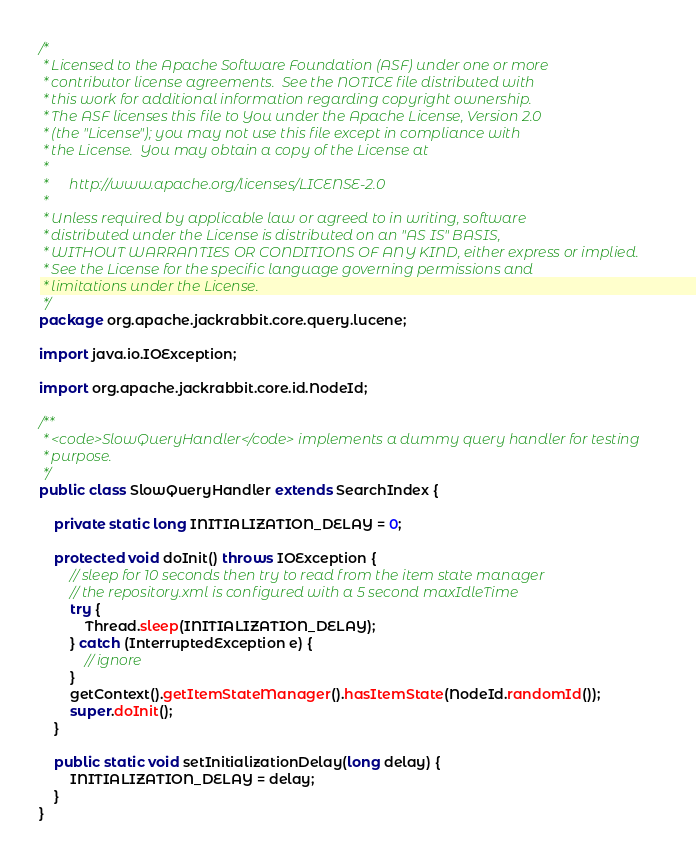<code> <loc_0><loc_0><loc_500><loc_500><_Java_>/*
 * Licensed to the Apache Software Foundation (ASF) under one or more
 * contributor license agreements.  See the NOTICE file distributed with
 * this work for additional information regarding copyright ownership.
 * The ASF licenses this file to You under the Apache License, Version 2.0
 * (the "License"); you may not use this file except in compliance with
 * the License.  You may obtain a copy of the License at
 *
 *      http://www.apache.org/licenses/LICENSE-2.0
 *
 * Unless required by applicable law or agreed to in writing, software
 * distributed under the License is distributed on an "AS IS" BASIS,
 * WITHOUT WARRANTIES OR CONDITIONS OF ANY KIND, either express or implied.
 * See the License for the specific language governing permissions and
 * limitations under the License.
 */
package org.apache.jackrabbit.core.query.lucene;

import java.io.IOException;

import org.apache.jackrabbit.core.id.NodeId;

/**
 * <code>SlowQueryHandler</code> implements a dummy query handler for testing
 * purpose.
 */
public class SlowQueryHandler extends SearchIndex {

    private static long INITIALIZATION_DELAY = 0;

    protected void doInit() throws IOException {
        // sleep for 10 seconds then try to read from the item state manager
        // the repository.xml is configured with a 5 second maxIdleTime
        try {
            Thread.sleep(INITIALIZATION_DELAY);
        } catch (InterruptedException e) {
            // ignore
        }
        getContext().getItemStateManager().hasItemState(NodeId.randomId());
        super.doInit();
    }

    public static void setInitializationDelay(long delay) {
        INITIALIZATION_DELAY = delay;
    }
}
</code> 